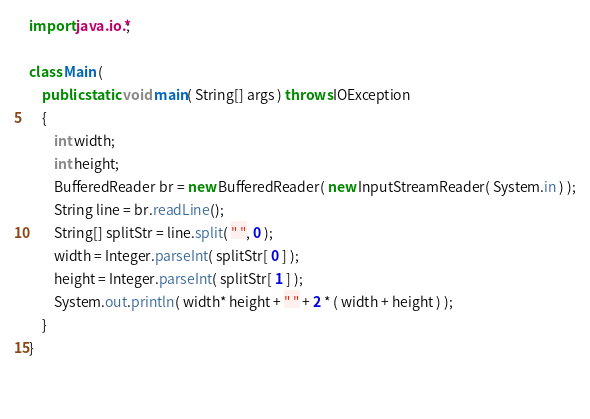Convert code to text. <code><loc_0><loc_0><loc_500><loc_500><_Java_>import java.io.*;

class Main (
    public static void main( String[] args ) throws IOException
    {
        int width;
        int height;
        BufferedReader br = new BufferedReader( new InputStreamReader( System.in ) );
        String line = br.readLine();
        String[] splitStr = line.split( " ", 0 );
        width = Integer.parseInt( splitStr[ 0 ] );
        height = Integer.parseInt( splitStr[ 1 ] );
        System.out.println( width* height + " " + 2 * ( width + height ) );
    }
}

        </code> 